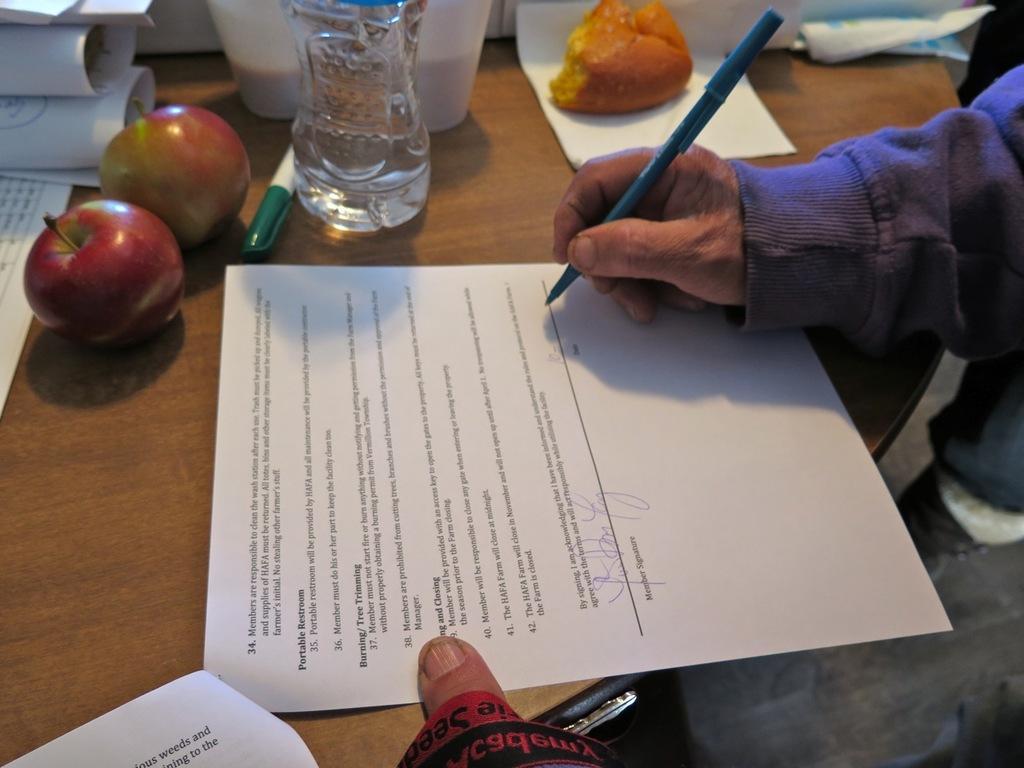Can you describe this image briefly? On a table there are food items,papers,pen and on the paper a person is signing. 